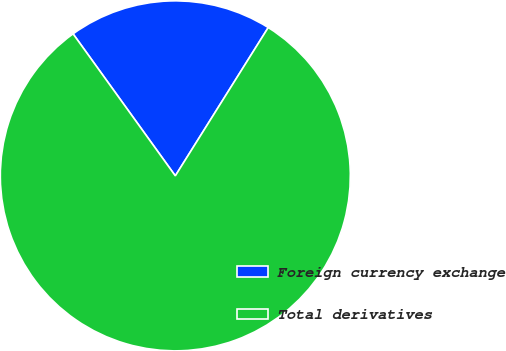Convert chart to OTSL. <chart><loc_0><loc_0><loc_500><loc_500><pie_chart><fcel>Foreign currency exchange<fcel>Total derivatives<nl><fcel>18.84%<fcel>81.16%<nl></chart> 